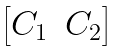Convert formula to latex. <formula><loc_0><loc_0><loc_500><loc_500>\begin{bmatrix} C _ { 1 } & C _ { 2 } \end{bmatrix}</formula> 